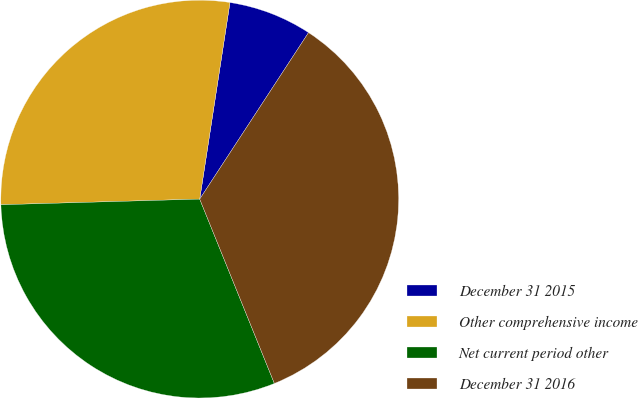<chart> <loc_0><loc_0><loc_500><loc_500><pie_chart><fcel>December 31 2015<fcel>Other comprehensive income<fcel>Net current period other<fcel>December 31 2016<nl><fcel>6.78%<fcel>27.88%<fcel>30.67%<fcel>34.66%<nl></chart> 